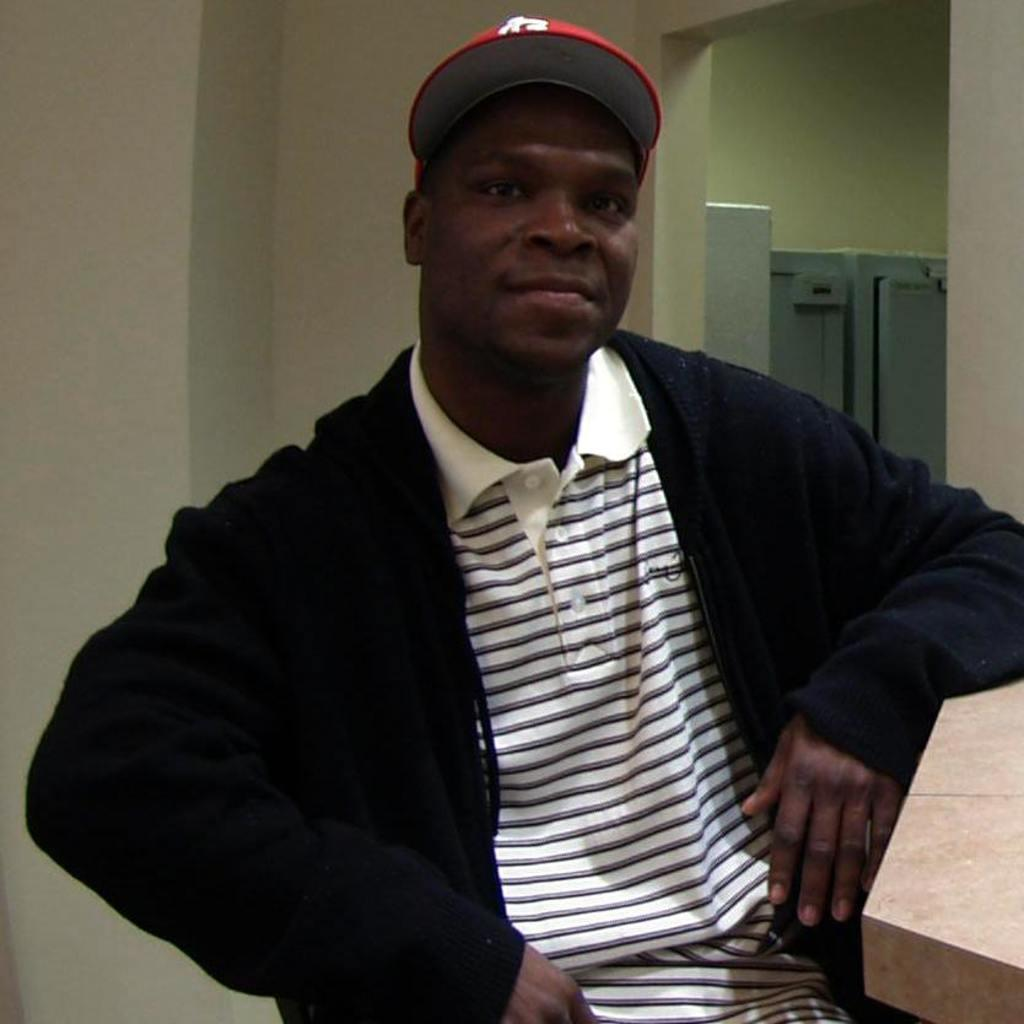What is the main subject of the image? The main subject of the image is a man. Can you describe the man's appearance? The man is wearing a cap and giving a pose. What is the man's facial expression? The man is smiling. What can be seen in the background of the image? There are walls and closed metal panels in the background. How do the metal panels resemble a door? The metal panels resemble a door because they are closed and have a similar shape. What type of humor can be seen in the man's pose in the image? There is no specific type of humor present in the man's pose in the image. Can you see any holes in the walls or metal panels in the image? There are no holes visible in the walls or metal panels in the image. 